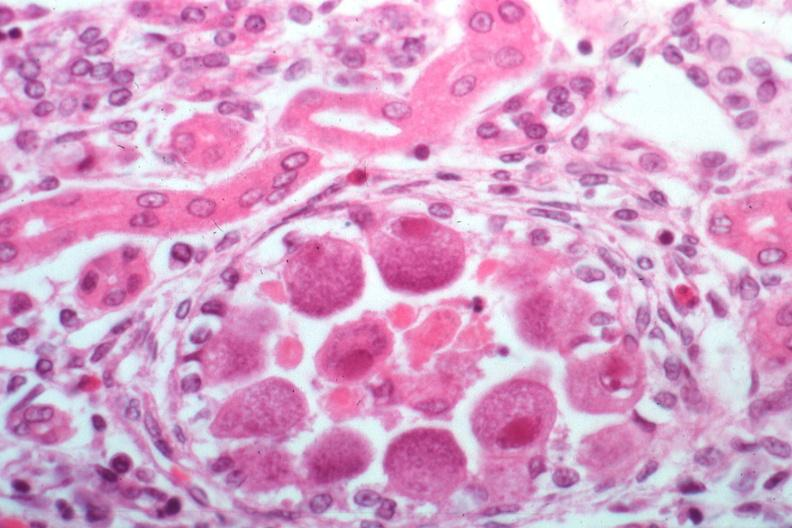what is present?
Answer the question using a single word or phrase. Cytomegalovirus 